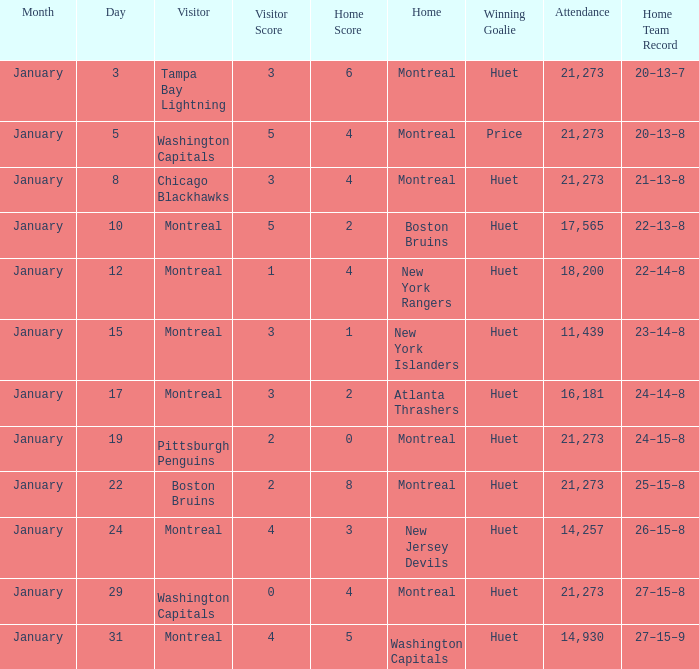What was the score of the game when the Boston Bruins were the visiting team? 2 – 8. 